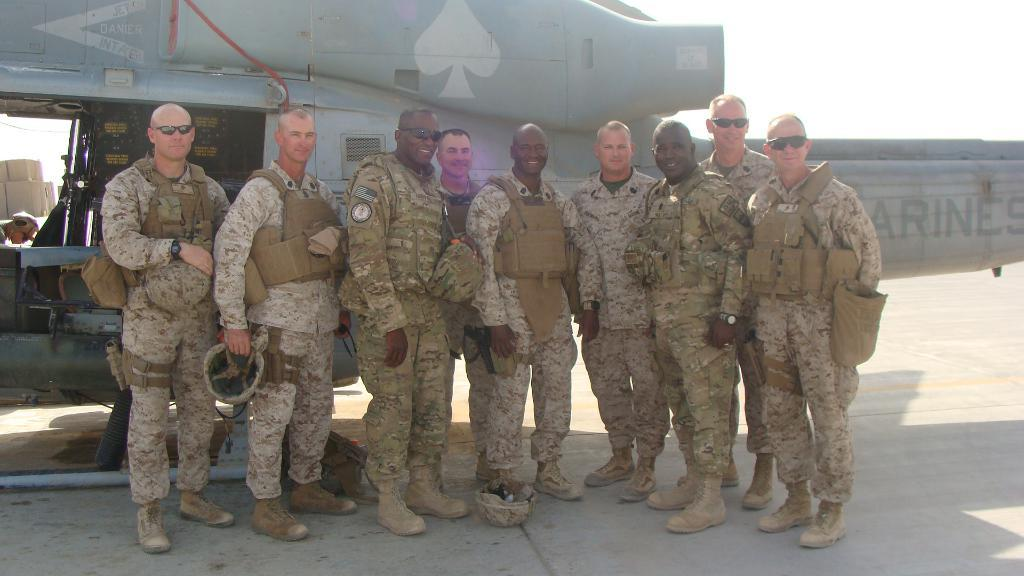How many army people are present in the image? There are 9 army people in the image. What are the army people doing in the image? The army people are standing in the image. What are the army people wearing? The army people are in uniforms. What expression do the army people have? The army people are smiling. What other object can be seen in the image besides the army people? There is a helicopter in the image. Who is visible inside the helicopter? A man is visible in the helicopter. How many cows are visible in the image? There are no cows present in the image. What type of dinosaurs can be seen interacting with the army people in the image? There are no dinosaurs present in the image. 